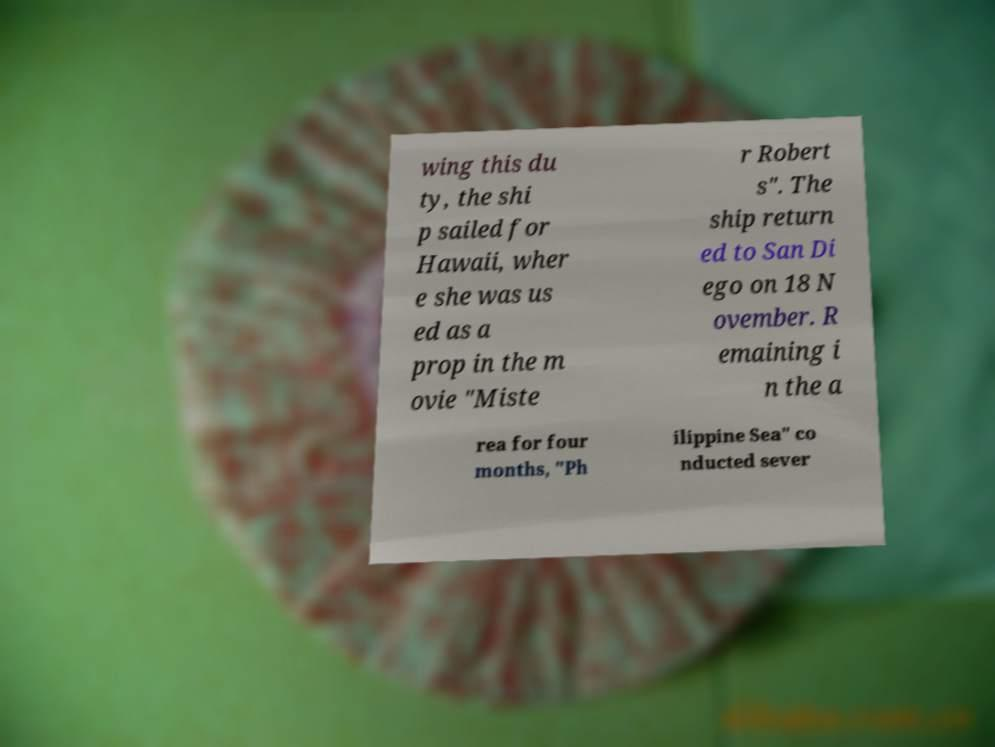Please identify and transcribe the text found in this image. wing this du ty, the shi p sailed for Hawaii, wher e she was us ed as a prop in the m ovie "Miste r Robert s". The ship return ed to San Di ego on 18 N ovember. R emaining i n the a rea for four months, "Ph ilippine Sea" co nducted sever 